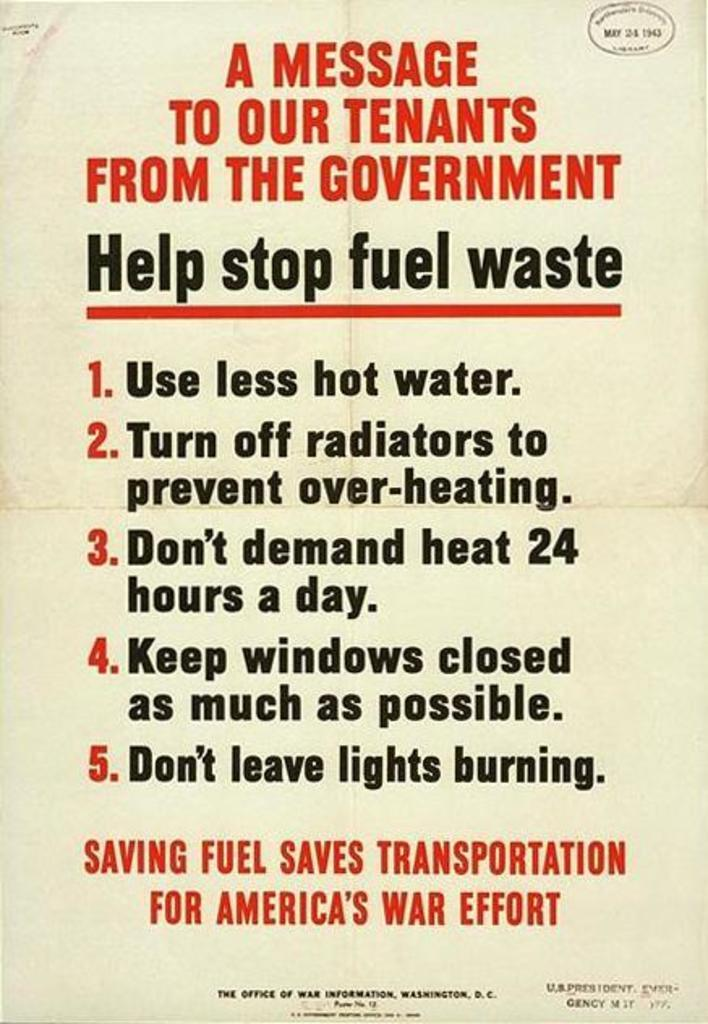<image>
Present a compact description of the photo's key features. the word fuel is on a sign with many numbers 